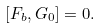Convert formula to latex. <formula><loc_0><loc_0><loc_500><loc_500>[ F _ { b } , G _ { 0 } ] = 0 .</formula> 